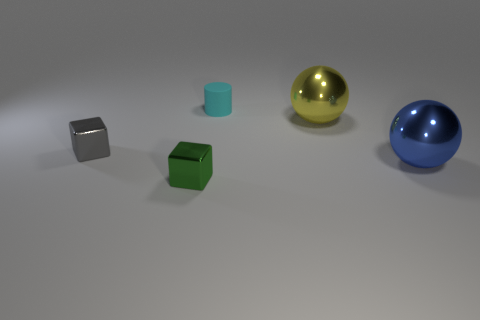Is there any other thing that has the same material as the small cyan object?
Give a very brief answer. No. What number of big objects are cyan rubber objects or blue shiny spheres?
Ensure brevity in your answer.  1. There is a large metallic thing behind the gray metallic object; what shape is it?
Your answer should be compact. Sphere. Is the size of the block that is on the right side of the tiny gray object the same as the gray metal object on the left side of the large yellow shiny ball?
Keep it short and to the point. Yes. Are there more small shiny blocks that are behind the tiny green shiny block than large yellow metal balls that are to the right of the blue metallic thing?
Offer a terse response. Yes. Are there any green cubes made of the same material as the large yellow ball?
Your answer should be very brief. Yes. There is a thing that is both to the left of the big yellow thing and behind the tiny gray block; what material is it?
Your answer should be very brief. Rubber. The rubber thing is what color?
Your response must be concise. Cyan. How many cyan things are the same shape as the blue object?
Your answer should be very brief. 0. Are the big object that is in front of the gray block and the small thing behind the tiny gray shiny block made of the same material?
Give a very brief answer. No. 